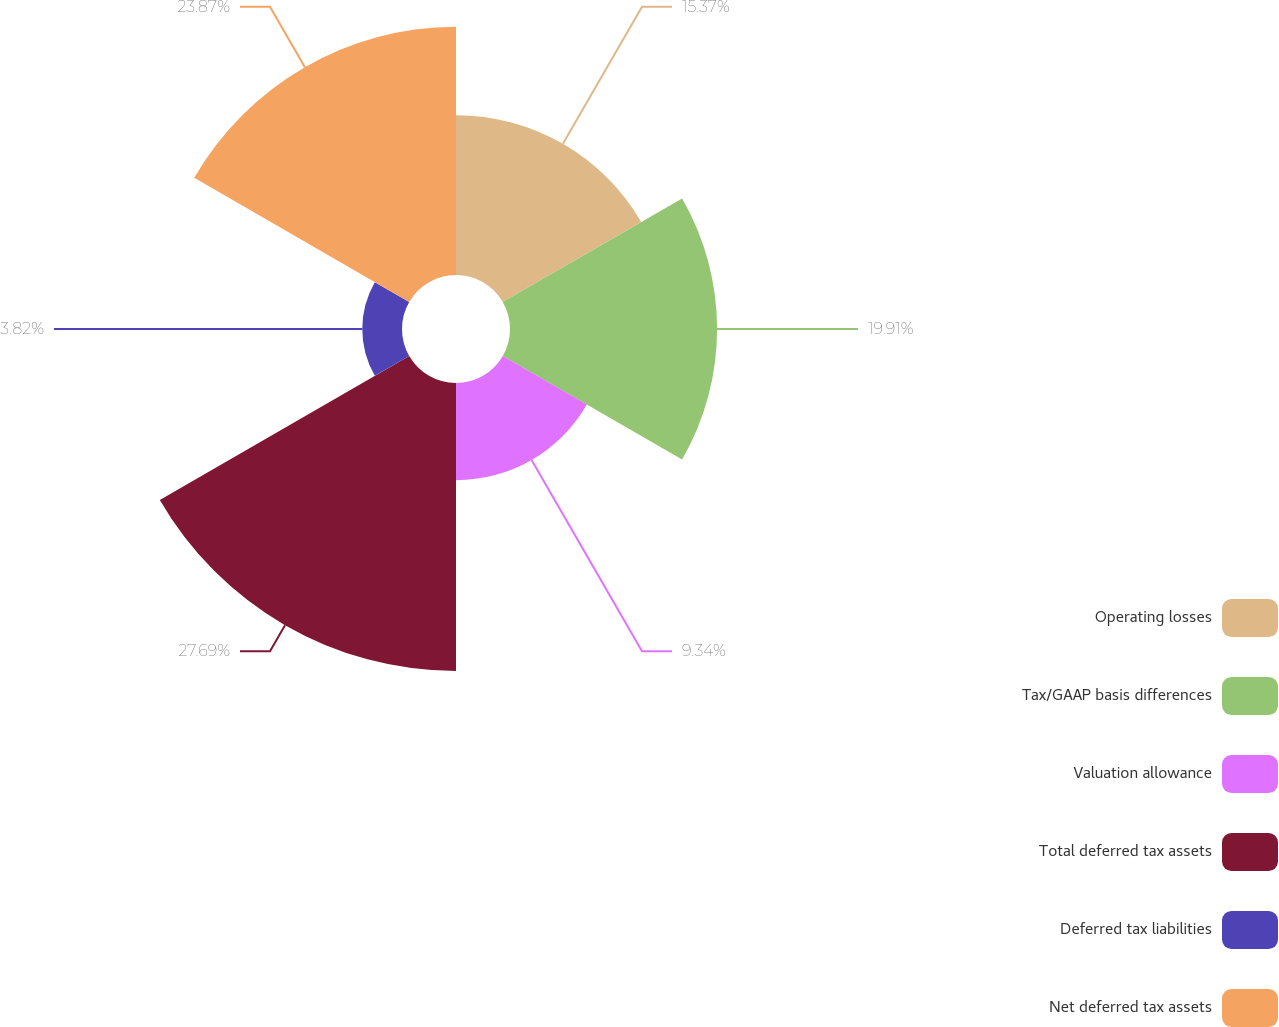<chart> <loc_0><loc_0><loc_500><loc_500><pie_chart><fcel>Operating losses<fcel>Tax/GAAP basis differences<fcel>Valuation allowance<fcel>Total deferred tax assets<fcel>Deferred tax liabilities<fcel>Net deferred tax assets<nl><fcel>15.37%<fcel>19.91%<fcel>9.34%<fcel>27.69%<fcel>3.82%<fcel>23.87%<nl></chart> 